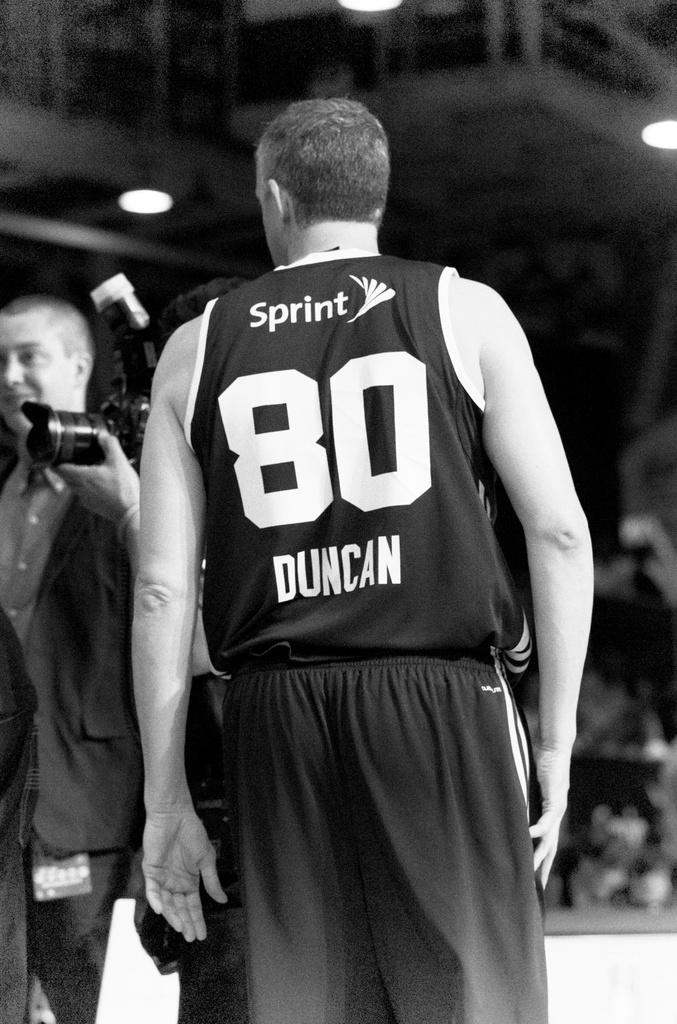<image>
Relay a brief, clear account of the picture shown. A man in a basketball jersey that says Sprint on the back. 